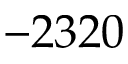<formula> <loc_0><loc_0><loc_500><loc_500>- 2 3 2 0</formula> 